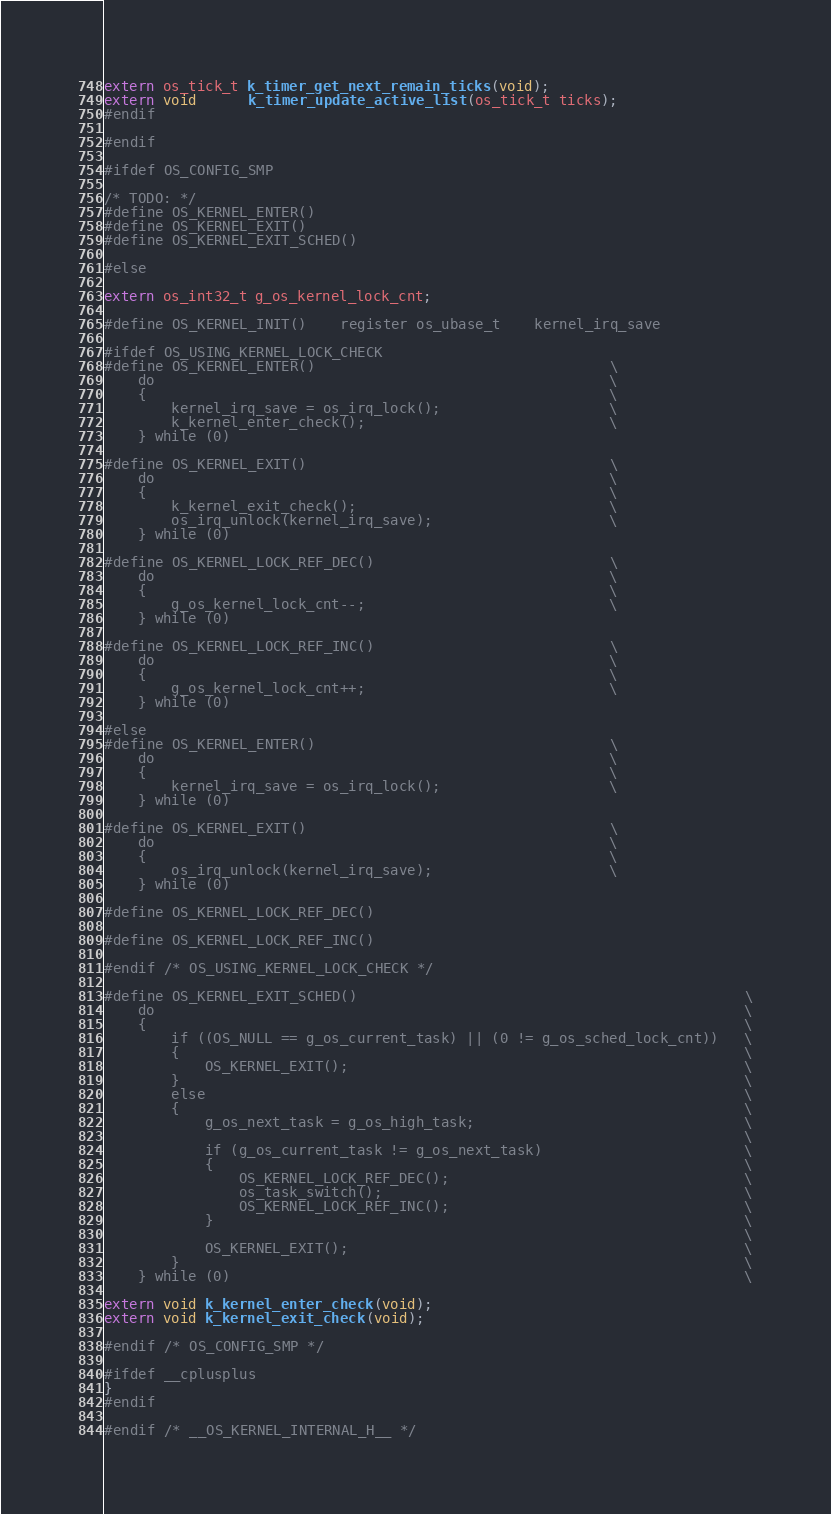Convert code to text. <code><loc_0><loc_0><loc_500><loc_500><_C_>extern os_tick_t k_timer_get_next_remain_ticks(void);
extern void      k_timer_update_active_list(os_tick_t ticks);
#endif

#endif

#ifdef OS_CONFIG_SMP

/* TODO: */
#define OS_KERNEL_ENTER()
#define OS_KERNEL_EXIT()
#define OS_KERNEL_EXIT_SCHED()

#else

extern os_int32_t g_os_kernel_lock_cnt;

#define OS_KERNEL_INIT()    register os_ubase_t    kernel_irq_save

#ifdef OS_USING_KERNEL_LOCK_CHECK
#define OS_KERNEL_ENTER()                                   \
    do                                                      \
    {                                                       \
        kernel_irq_save = os_irq_lock();                    \
        k_kernel_enter_check();                             \
    } while (0)

#define OS_KERNEL_EXIT()                                    \
    do                                                      \
    {                                                       \
        k_kernel_exit_check();                              \
        os_irq_unlock(kernel_irq_save);                     \
    } while (0)

#define OS_KERNEL_LOCK_REF_DEC()                            \
    do                                                      \
    {                                                       \
        g_os_kernel_lock_cnt--;                             \
    } while (0) 

#define OS_KERNEL_LOCK_REF_INC()                            \
    do                                                      \
    {                                                       \
        g_os_kernel_lock_cnt++;                             \
    } while (0)
 
#else
#define OS_KERNEL_ENTER()                                   \
    do                                                      \
    {                                                       \
        kernel_irq_save = os_irq_lock();                    \
    } while (0)

#define OS_KERNEL_EXIT()                                    \
    do                                                      \
    {                                                       \
        os_irq_unlock(kernel_irq_save);                     \
    } while (0)

#define OS_KERNEL_LOCK_REF_DEC()

#define OS_KERNEL_LOCK_REF_INC()

#endif /* OS_USING_KERNEL_LOCK_CHECK */

#define OS_KERNEL_EXIT_SCHED()                                              \
    do                                                                      \
    {                                                                       \
        if ((OS_NULL == g_os_current_task) || (0 != g_os_sched_lock_cnt))   \
        {                                                                   \
            OS_KERNEL_EXIT();                                               \
        }                                                                   \
        else                                                                \
        {                                                                   \
            g_os_next_task = g_os_high_task;                                \
                                                                            \
            if (g_os_current_task != g_os_next_task)                        \
            {                                                               \
                OS_KERNEL_LOCK_REF_DEC();                                   \
                os_task_switch();                                           \
                OS_KERNEL_LOCK_REF_INC();                                   \
            }                                                               \
                                                                            \
            OS_KERNEL_EXIT();                                               \
        }                                                                   \
    } while (0)                                                             \

extern void k_kernel_enter_check(void);
extern void k_kernel_exit_check(void);

#endif /* OS_CONFIG_SMP */

#ifdef __cplusplus
}
#endif

#endif /* __OS_KERNEL_INTERNAL_H__ */

</code> 